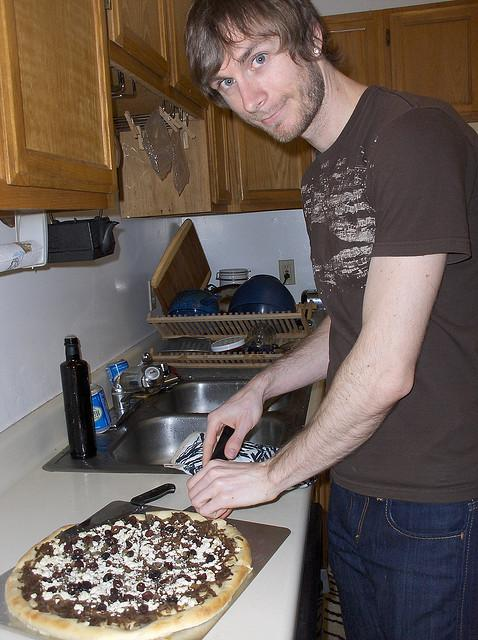What company is known for making the item that is on the counter?

Choices:
A) domino's
B) mcdonald's
C) nathan's
D) gorton's domino's 